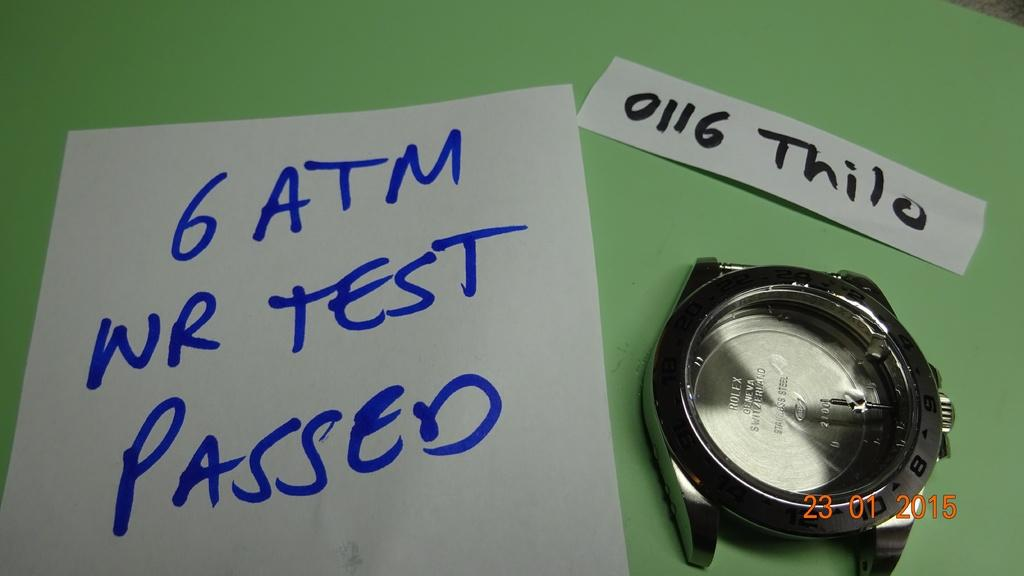Provide a one-sentence caption for the provided image. A broken watch on a table with a note that reads 6 ATM WR TEST PASSED. 